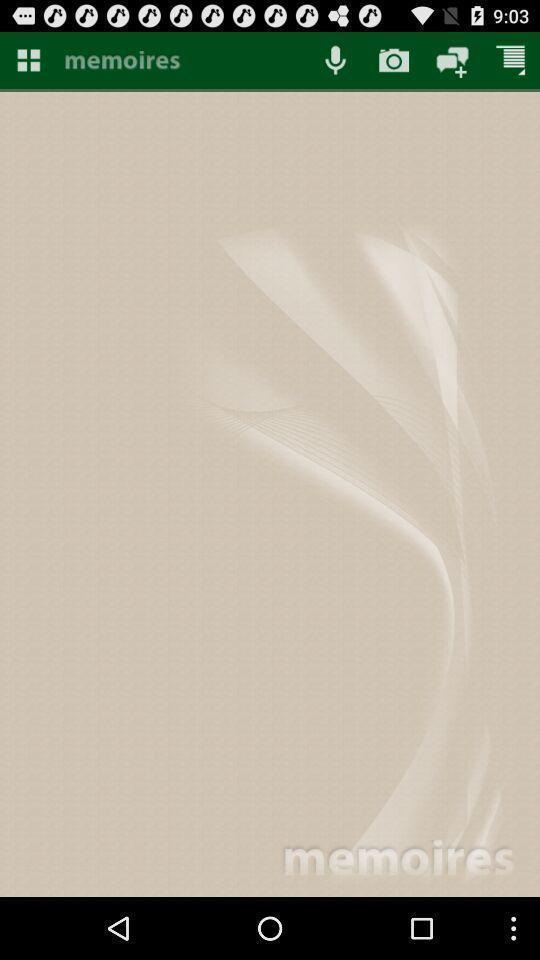Provide a textual representation of this image. Screen displaying memories page of an ap. 